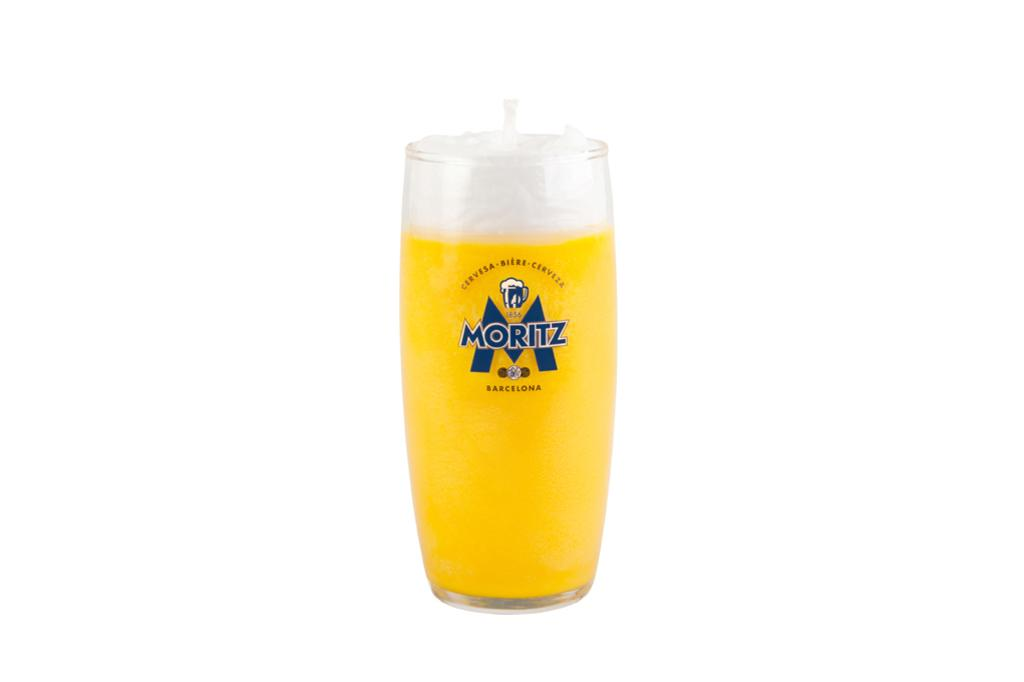<image>
Write a terse but informative summary of the picture. A large glass completely full of Moritz beer. 